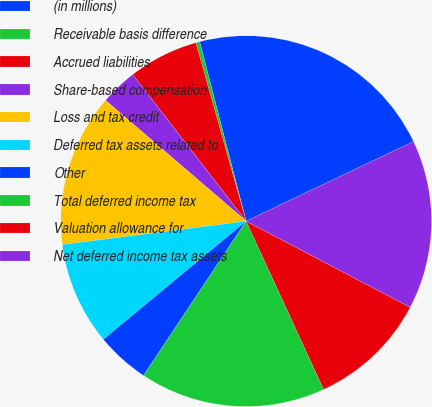Convert chart to OTSL. <chart><loc_0><loc_0><loc_500><loc_500><pie_chart><fcel>(in millions)<fcel>Receivable basis difference<fcel>Accrued liabilities<fcel>Share-based compensation<fcel>Loss and tax credit<fcel>Deferred tax assets related to<fcel>Other<fcel>Total deferred income tax<fcel>Valuation allowance for<fcel>Net deferred income tax assets<nl><fcel>21.97%<fcel>0.34%<fcel>6.11%<fcel>3.22%<fcel>13.32%<fcel>8.99%<fcel>4.66%<fcel>16.2%<fcel>10.43%<fcel>14.76%<nl></chart> 